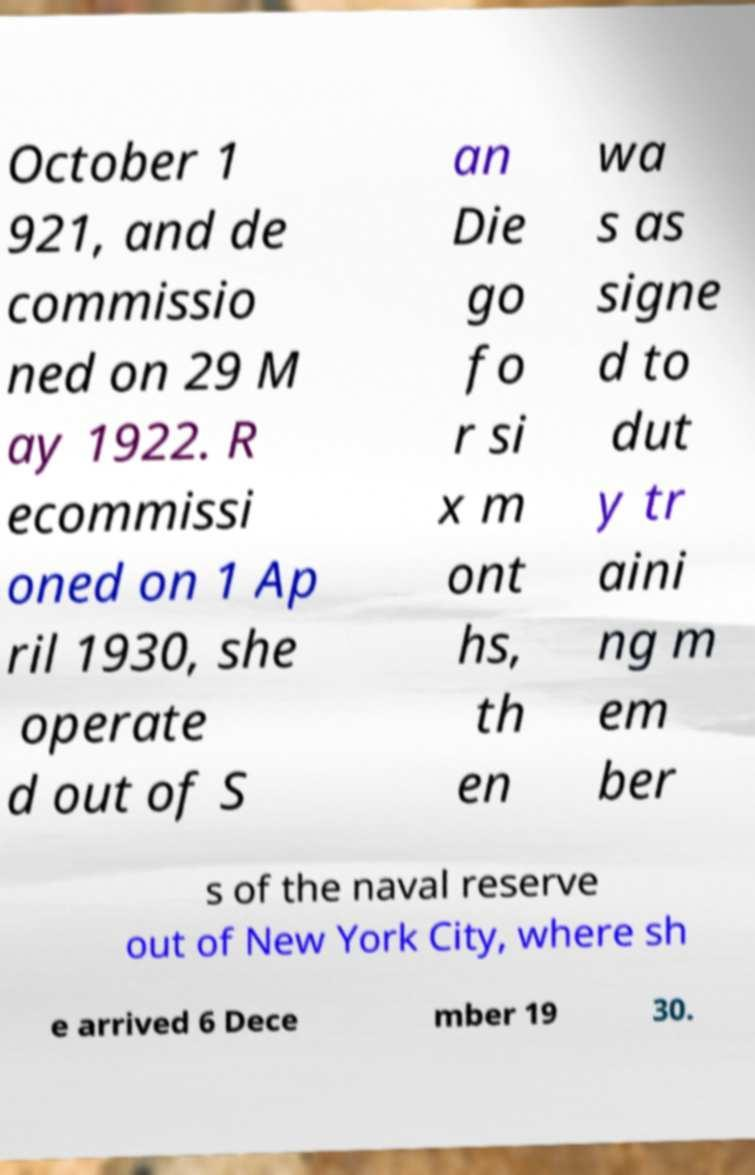Please identify and transcribe the text found in this image. October 1 921, and de commissio ned on 29 M ay 1922. R ecommissi oned on 1 Ap ril 1930, she operate d out of S an Die go fo r si x m ont hs, th en wa s as signe d to dut y tr aini ng m em ber s of the naval reserve out of New York City, where sh e arrived 6 Dece mber 19 30. 